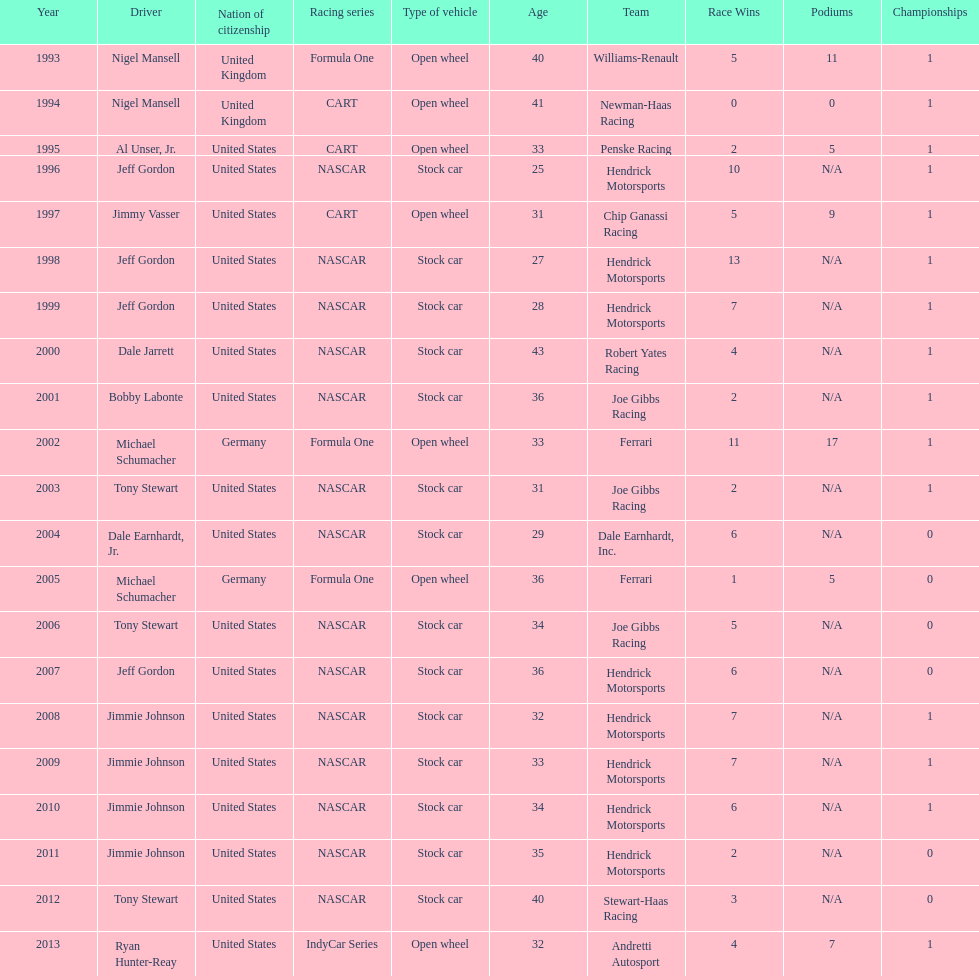Which driver had four consecutive wins? Jimmie Johnson. 